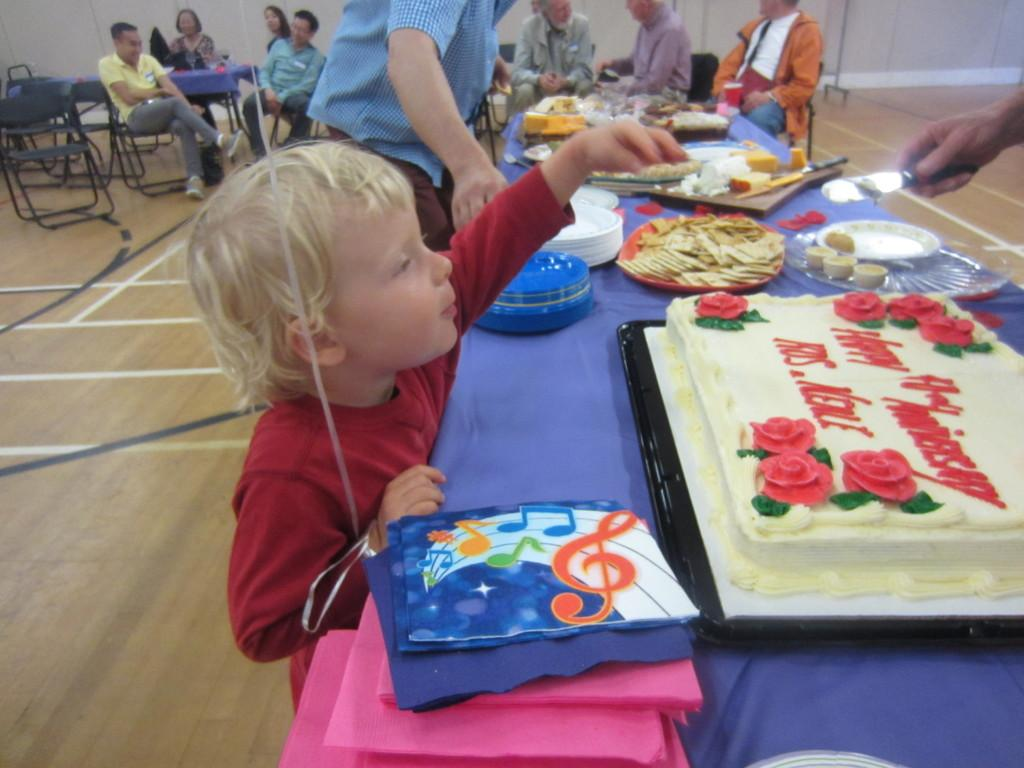What are the people in the image doing? The people in the image are seated on chairs. Are there any other individuals in the image besides those seated? Yes, there is a boy standing in the image, as well as a man standing. What is on the table in the image? There is a cake and food on the table in the image. What type of pear is being used as a decoration on the cake in the image? There is no pear present on the cake in the image. 